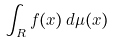Convert formula to latex. <formula><loc_0><loc_0><loc_500><loc_500>\int _ { R } f ( x ) \, d \mu ( x )</formula> 